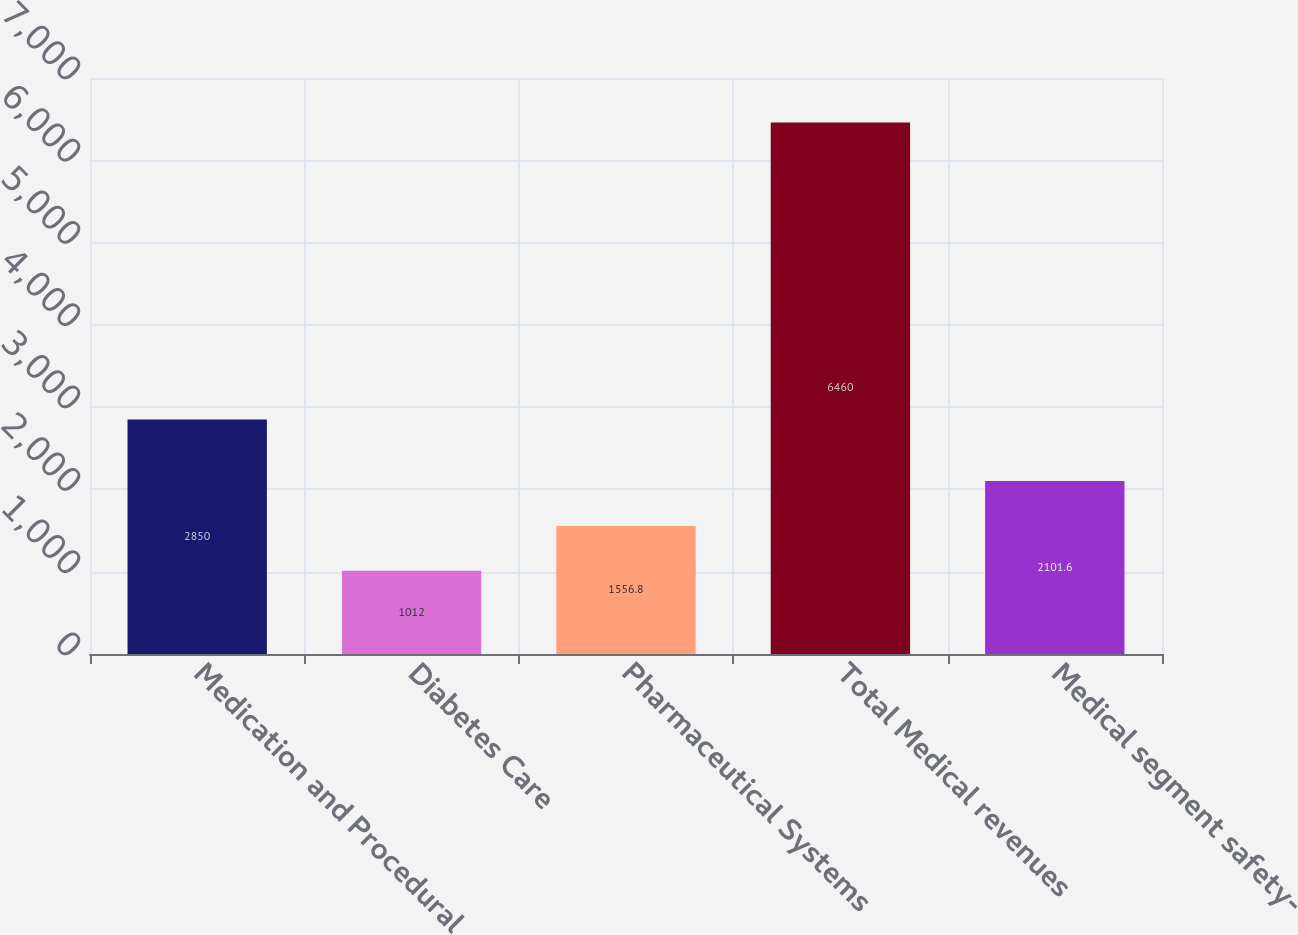Convert chart. <chart><loc_0><loc_0><loc_500><loc_500><bar_chart><fcel>Medication and Procedural<fcel>Diabetes Care<fcel>Pharmaceutical Systems<fcel>Total Medical revenues<fcel>Medical segment safety-<nl><fcel>2850<fcel>1012<fcel>1556.8<fcel>6460<fcel>2101.6<nl></chart> 